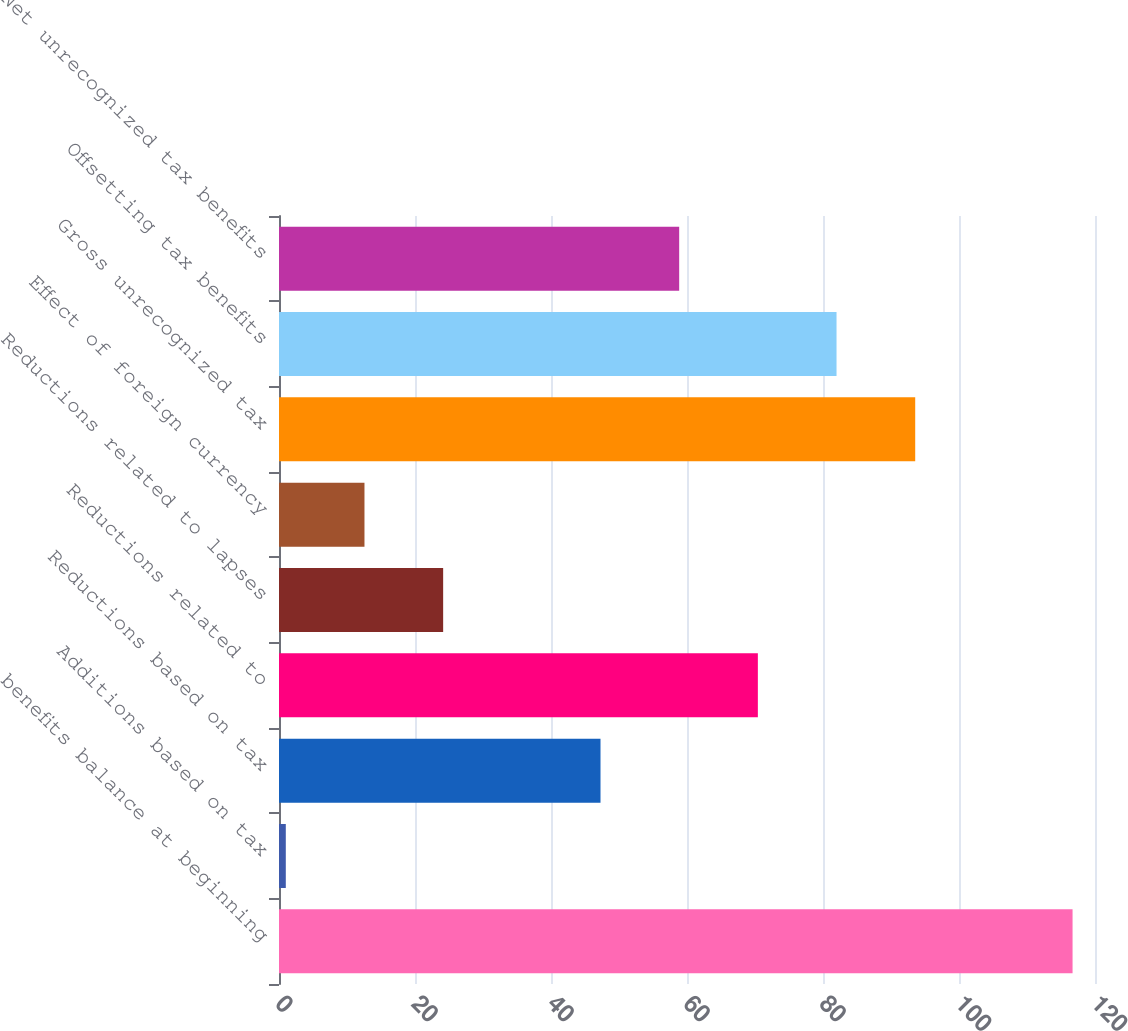<chart> <loc_0><loc_0><loc_500><loc_500><bar_chart><fcel>benefits balance at beginning<fcel>Additions based on tax<fcel>Reductions based on tax<fcel>Reductions related to<fcel>Reductions related to lapses<fcel>Effect of foreign currency<fcel>Gross unrecognized tax<fcel>Offsetting tax benefits<fcel>Net unrecognized tax benefits<nl><fcel>116.7<fcel>1<fcel>47.28<fcel>70.42<fcel>24.14<fcel>12.57<fcel>93.56<fcel>81.99<fcel>58.85<nl></chart> 